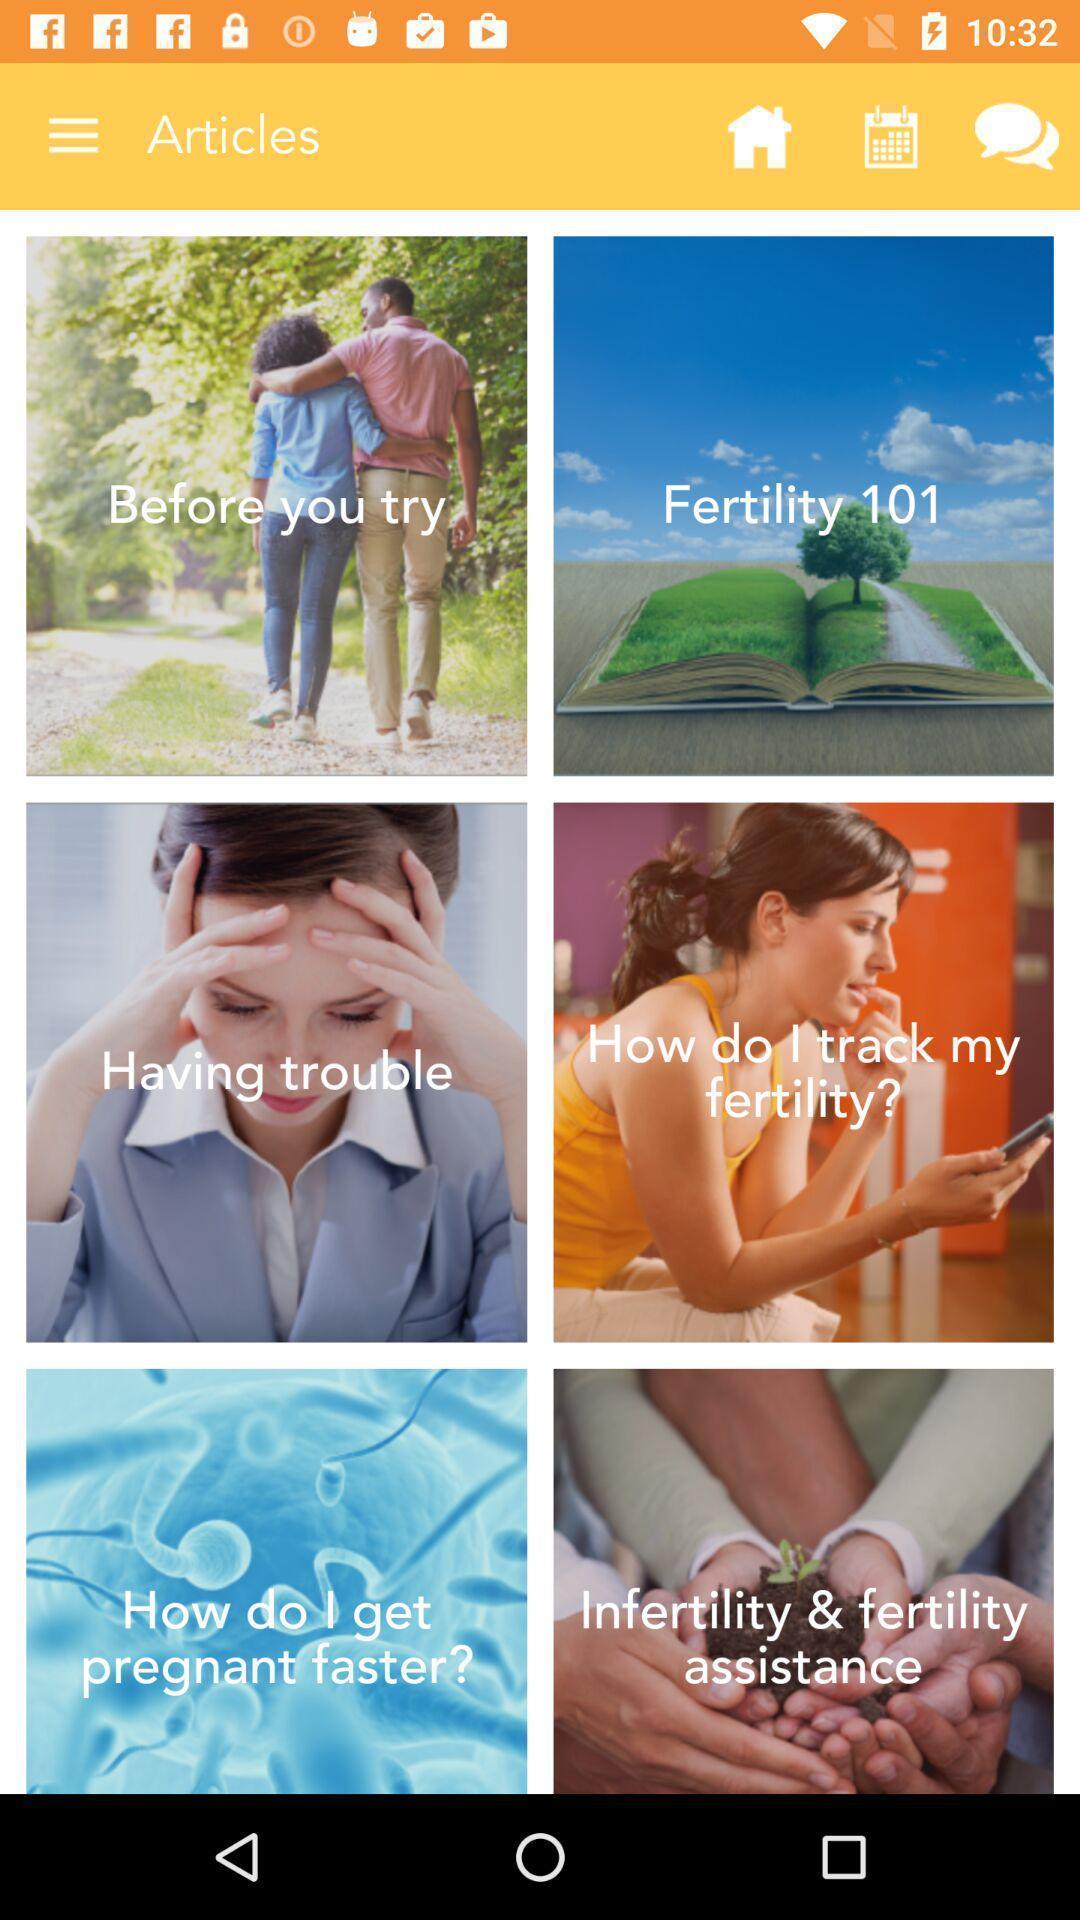Describe the visual elements of this screenshot. Page showing multiple thumbnails in articles tab. 